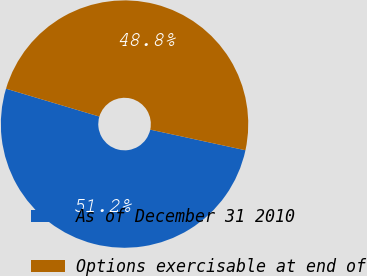Convert chart. <chart><loc_0><loc_0><loc_500><loc_500><pie_chart><fcel>As of December 31 2010<fcel>Options exercisable at end of<nl><fcel>51.22%<fcel>48.78%<nl></chart> 